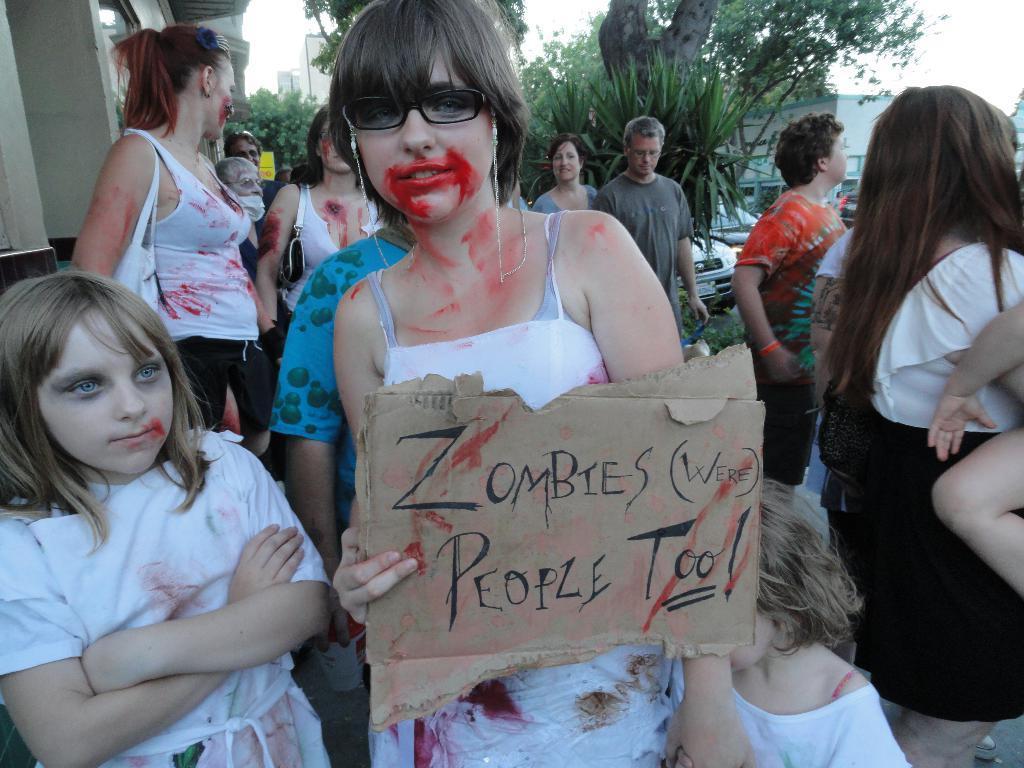Can you describe this image briefly? In the center of the image we can see a woman wearing the glasses and holding the text board. We can also see the kids. In the background we can see the people. We can also see the buildings, trees and also the vehicles. Sky is also visible in this image. 